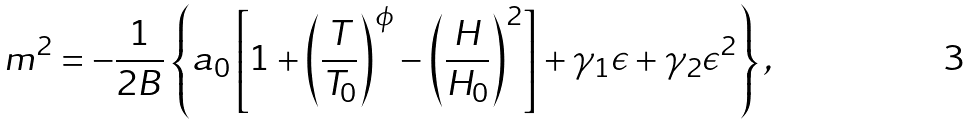Convert formula to latex. <formula><loc_0><loc_0><loc_500><loc_500>m ^ { 2 } = - \frac { 1 } { 2 B } \left \{ a _ { 0 } \left [ 1 + \left ( \frac { T } { T _ { 0 } } \right ) ^ { \phi } - \left ( \frac { H } { H _ { 0 } } \right ) ^ { 2 } \right ] + \gamma _ { 1 } \epsilon + \gamma _ { 2 } \epsilon ^ { 2 } \right \} ,</formula> 